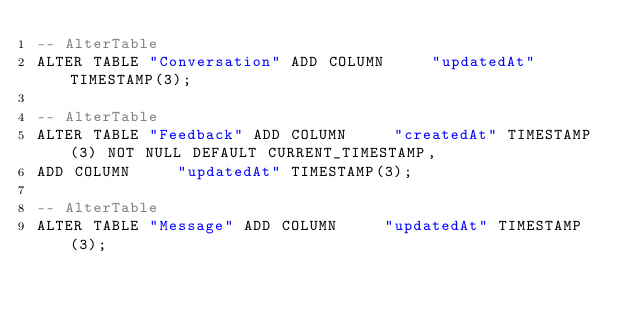<code> <loc_0><loc_0><loc_500><loc_500><_SQL_>-- AlterTable
ALTER TABLE "Conversation" ADD COLUMN     "updatedAt" TIMESTAMP(3);

-- AlterTable
ALTER TABLE "Feedback" ADD COLUMN     "createdAt" TIMESTAMP(3) NOT NULL DEFAULT CURRENT_TIMESTAMP,
ADD COLUMN     "updatedAt" TIMESTAMP(3);

-- AlterTable
ALTER TABLE "Message" ADD COLUMN     "updatedAt" TIMESTAMP(3);
</code> 